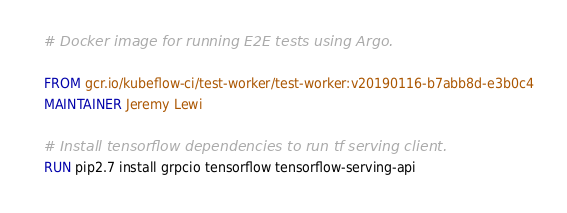<code> <loc_0><loc_0><loc_500><loc_500><_Dockerfile_># Docker image for running E2E tests using Argo.

FROM gcr.io/kubeflow-ci/test-worker/test-worker:v20190116-b7abb8d-e3b0c4
MAINTAINER Jeremy Lewi

# Install tensorflow dependencies to run tf serving client.
RUN pip2.7 install grpcio tensorflow tensorflow-serving-api
</code> 